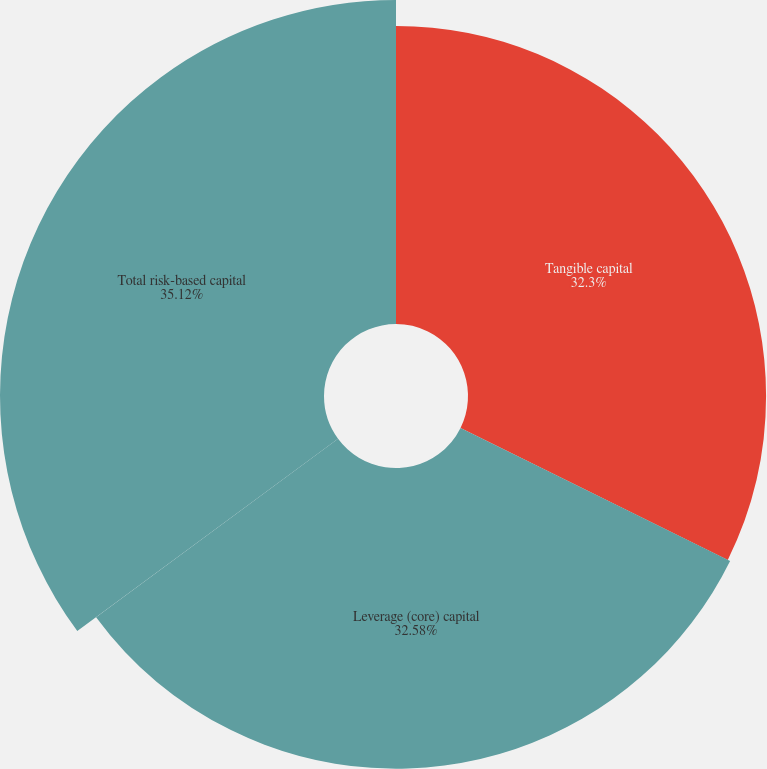Convert chart. <chart><loc_0><loc_0><loc_500><loc_500><pie_chart><fcel>Tangible capital<fcel>Leverage (core) capital<fcel>Total risk-based capital<nl><fcel>32.3%<fcel>32.58%<fcel>35.11%<nl></chart> 